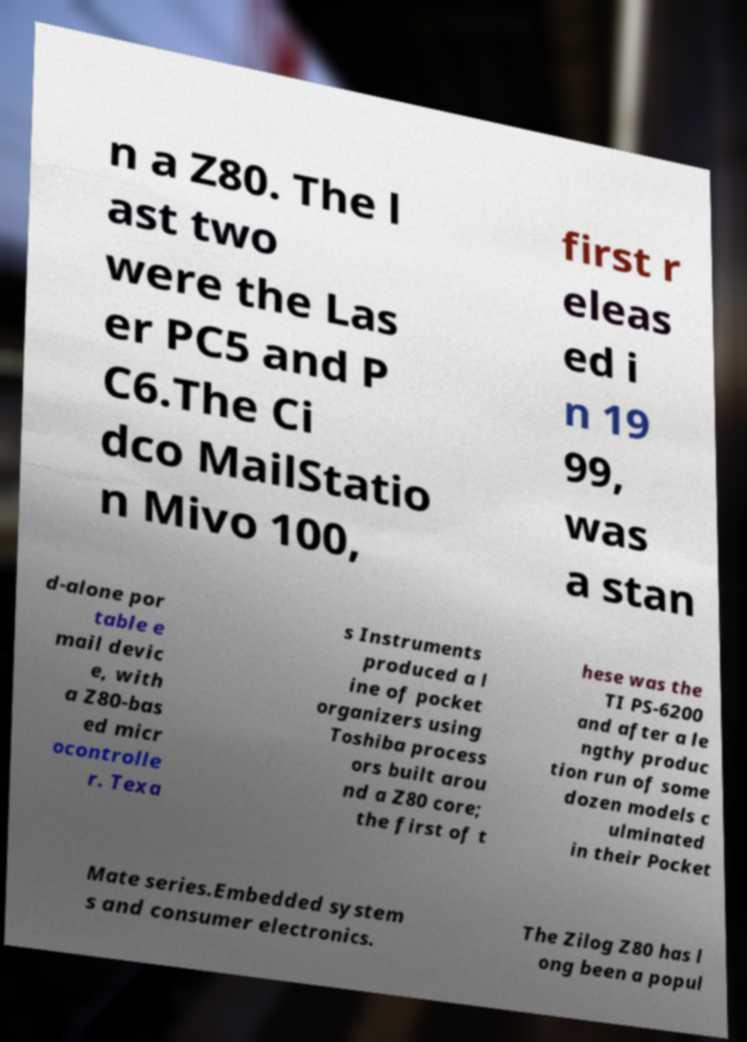There's text embedded in this image that I need extracted. Can you transcribe it verbatim? n a Z80. The l ast two were the Las er PC5 and P C6.The Ci dco MailStatio n Mivo 100, first r eleas ed i n 19 99, was a stan d-alone por table e mail devic e, with a Z80-bas ed micr ocontrolle r. Texa s Instruments produced a l ine of pocket organizers using Toshiba process ors built arou nd a Z80 core; the first of t hese was the TI PS-6200 and after a le ngthy produc tion run of some dozen models c ulminated in their Pocket Mate series.Embedded system s and consumer electronics. The Zilog Z80 has l ong been a popul 